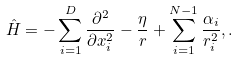Convert formula to latex. <formula><loc_0><loc_0><loc_500><loc_500>\hat { H } = - \sum _ { i = 1 } ^ { D } \frac { \partial ^ { 2 } } { \partial x _ { i } ^ { 2 } } - \frac { \eta } { r } + \sum _ { i = 1 } ^ { N - 1 } \frac { \alpha _ { i } } { r _ { i } ^ { 2 } } , .</formula> 